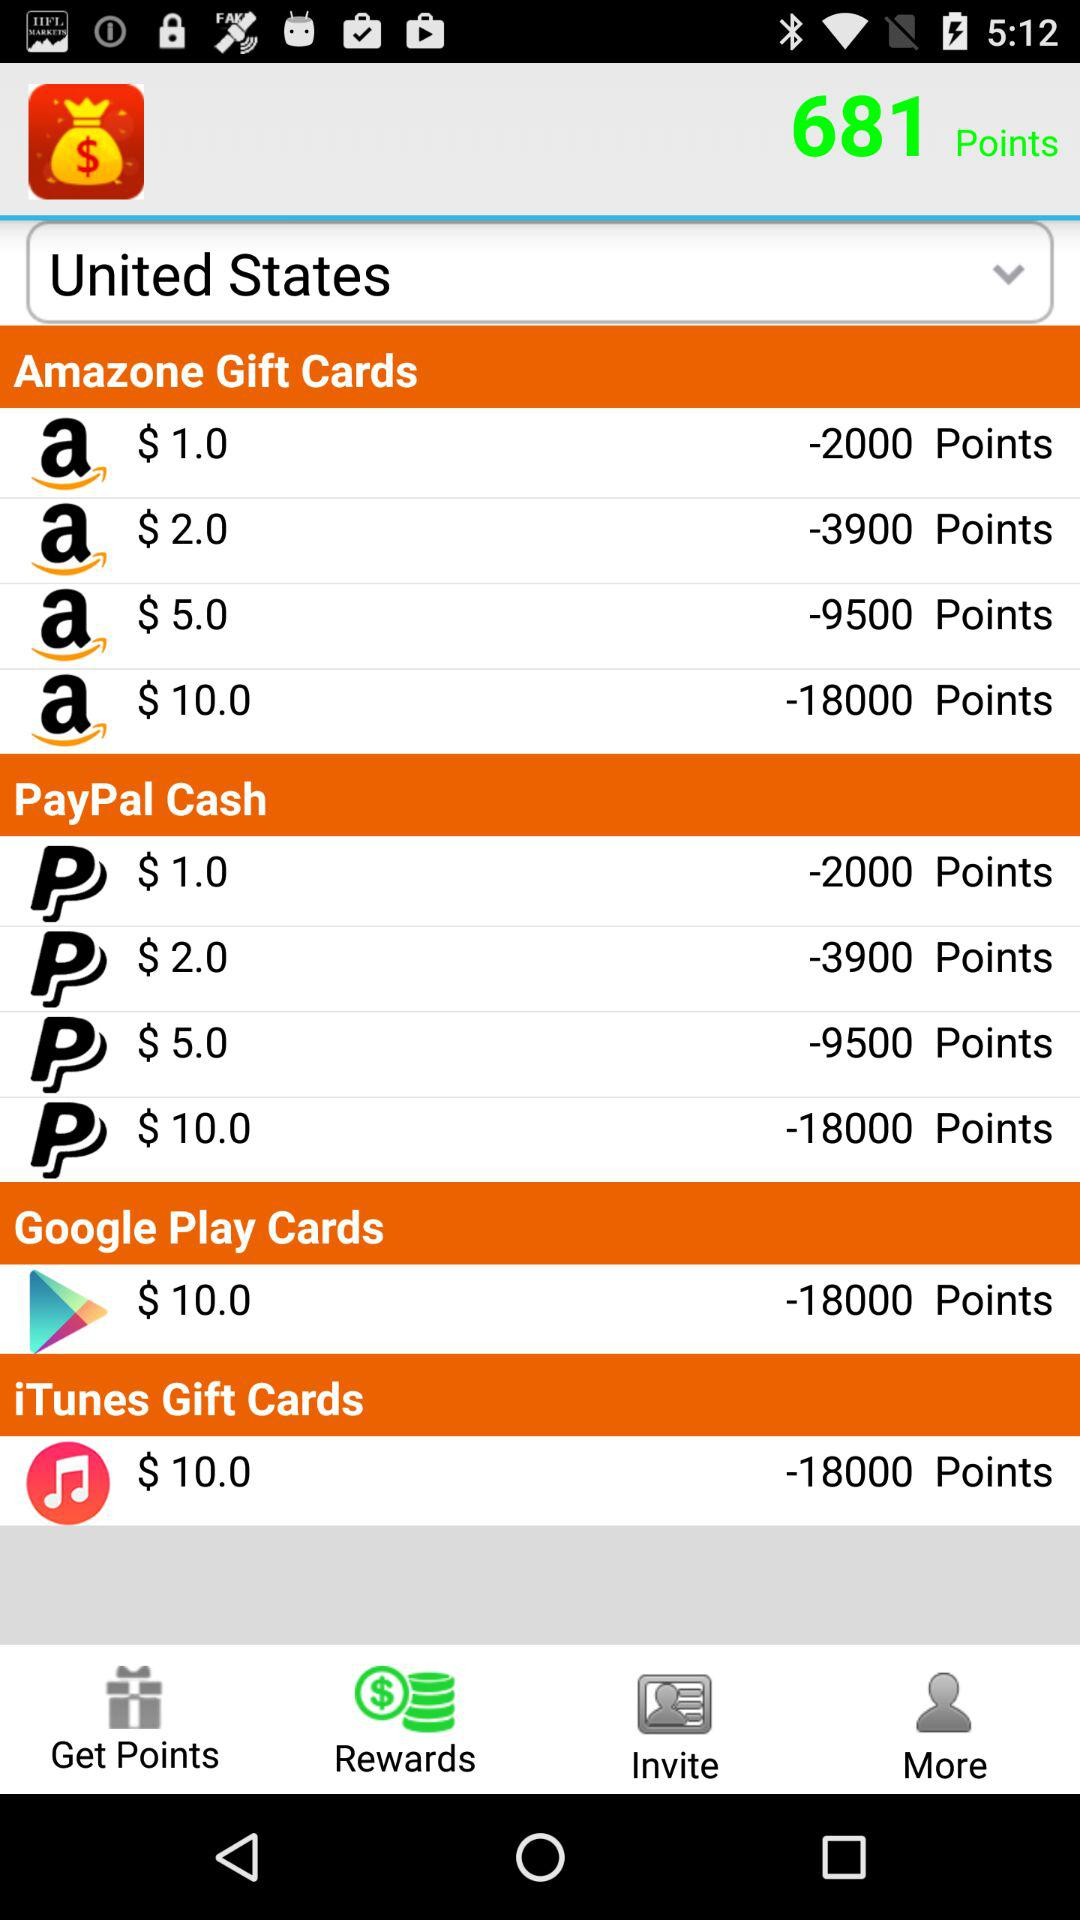Which tab is selected? The selected tab is "Rewards". 